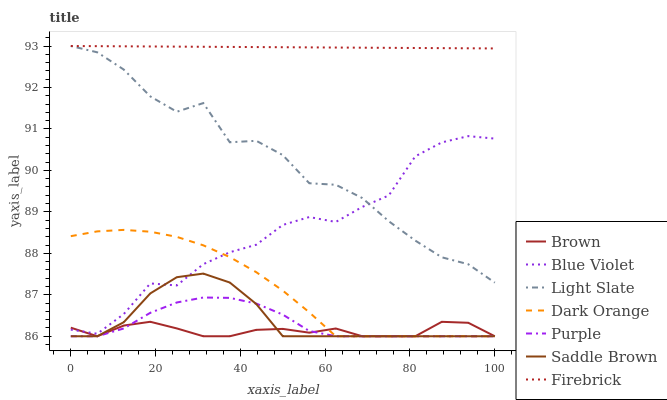Does Brown have the minimum area under the curve?
Answer yes or no. Yes. Does Firebrick have the maximum area under the curve?
Answer yes or no. Yes. Does Dark Orange have the minimum area under the curve?
Answer yes or no. No. Does Dark Orange have the maximum area under the curve?
Answer yes or no. No. Is Firebrick the smoothest?
Answer yes or no. Yes. Is Light Slate the roughest?
Answer yes or no. Yes. Is Dark Orange the smoothest?
Answer yes or no. No. Is Dark Orange the roughest?
Answer yes or no. No. Does Light Slate have the lowest value?
Answer yes or no. No. Does Firebrick have the highest value?
Answer yes or no. Yes. Does Dark Orange have the highest value?
Answer yes or no. No. Is Purple less than Firebrick?
Answer yes or no. Yes. Is Light Slate greater than Saddle Brown?
Answer yes or no. Yes. Does Dark Orange intersect Blue Violet?
Answer yes or no. Yes. Is Dark Orange less than Blue Violet?
Answer yes or no. No. Is Dark Orange greater than Blue Violet?
Answer yes or no. No. Does Purple intersect Firebrick?
Answer yes or no. No. 